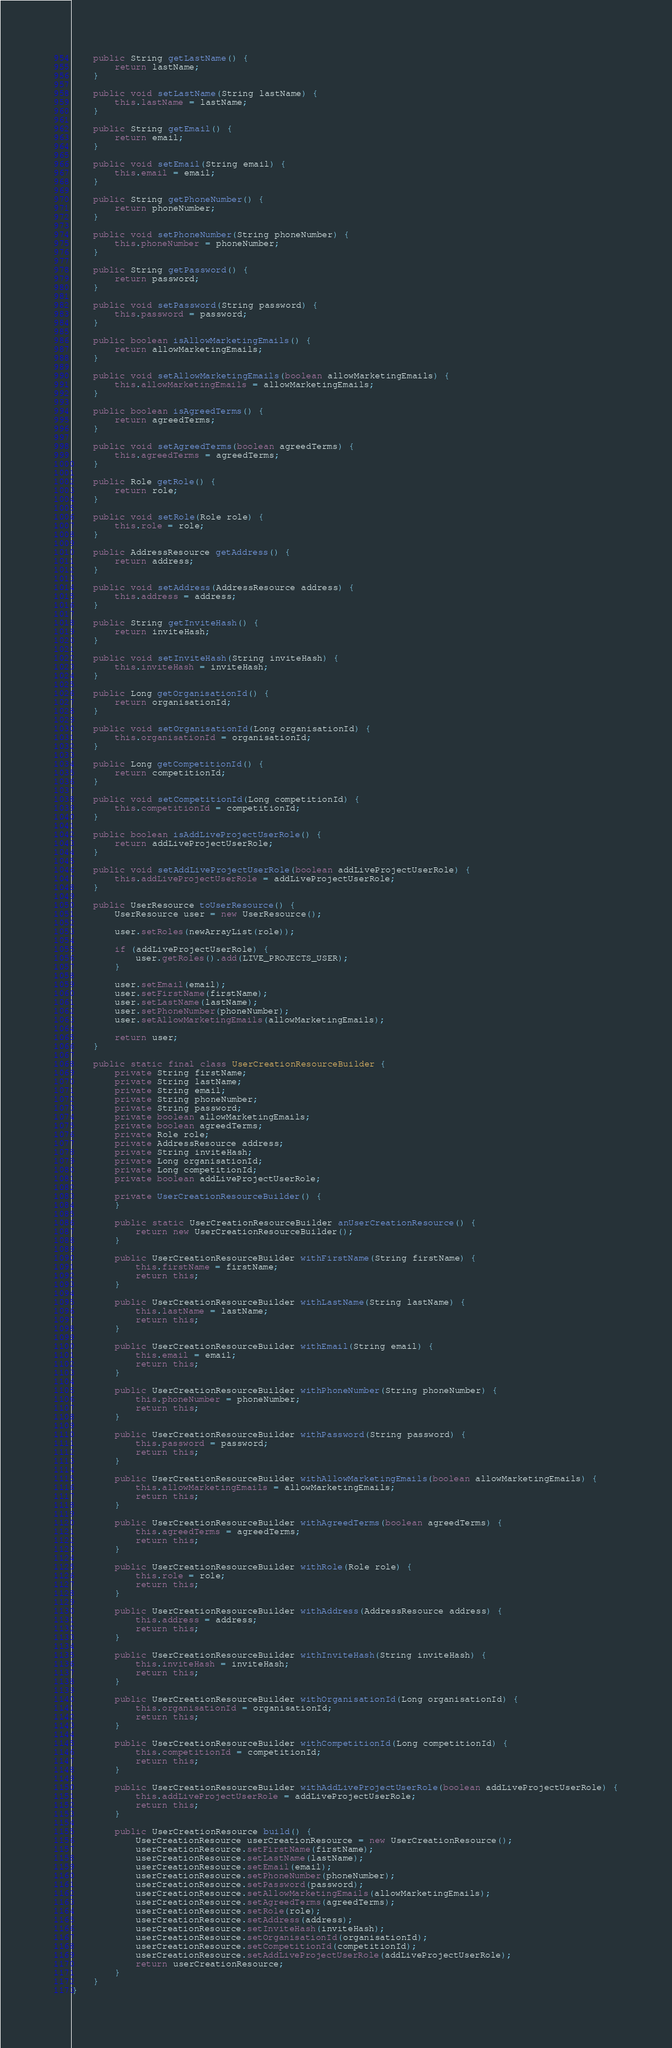Convert code to text. <code><loc_0><loc_0><loc_500><loc_500><_Java_>    public String getLastName() {
        return lastName;
    }

    public void setLastName(String lastName) {
        this.lastName = lastName;
    }

    public String getEmail() {
        return email;
    }

    public void setEmail(String email) {
        this.email = email;
    }

    public String getPhoneNumber() {
        return phoneNumber;
    }

    public void setPhoneNumber(String phoneNumber) {
        this.phoneNumber = phoneNumber;
    }

    public String getPassword() {
        return password;
    }

    public void setPassword(String password) {
        this.password = password;
    }

    public boolean isAllowMarketingEmails() {
        return allowMarketingEmails;
    }

    public void setAllowMarketingEmails(boolean allowMarketingEmails) {
        this.allowMarketingEmails = allowMarketingEmails;
    }

    public boolean isAgreedTerms() {
        return agreedTerms;
    }

    public void setAgreedTerms(boolean agreedTerms) {
        this.agreedTerms = agreedTerms;
    }

    public Role getRole() {
        return role;
    }

    public void setRole(Role role) {
        this.role = role;
    }

    public AddressResource getAddress() {
        return address;
    }

    public void setAddress(AddressResource address) {
        this.address = address;
    }

    public String getInviteHash() {
        return inviteHash;
    }

    public void setInviteHash(String inviteHash) {
        this.inviteHash = inviteHash;
    }

    public Long getOrganisationId() {
        return organisationId;
    }

    public void setOrganisationId(Long organisationId) {
        this.organisationId = organisationId;
    }

    public Long getCompetitionId() {
        return competitionId;
    }

    public void setCompetitionId(Long competitionId) {
        this.competitionId = competitionId;
    }

    public boolean isAddLiveProjectUserRole() {
        return addLiveProjectUserRole;
    }

    public void setAddLiveProjectUserRole(boolean addLiveProjectUserRole) {
        this.addLiveProjectUserRole = addLiveProjectUserRole;
    }

    public UserResource toUserResource() {
        UserResource user = new UserResource();

        user.setRoles(newArrayList(role));

        if (addLiveProjectUserRole) {
            user.getRoles().add(LIVE_PROJECTS_USER);
        }

        user.setEmail(email);
        user.setFirstName(firstName);
        user.setLastName(lastName);
        user.setPhoneNumber(phoneNumber);
        user.setAllowMarketingEmails(allowMarketingEmails);

        return user;
    }

    public static final class UserCreationResourceBuilder {
        private String firstName;
        private String lastName;
        private String email;
        private String phoneNumber;
        private String password;
        private boolean allowMarketingEmails;
        private boolean agreedTerms;
        private Role role;
        private AddressResource address;
        private String inviteHash;
        private Long organisationId;
        private Long competitionId;
        private boolean addLiveProjectUserRole;

        private UserCreationResourceBuilder() {
        }

        public static UserCreationResourceBuilder anUserCreationResource() {
            return new UserCreationResourceBuilder();
        }

        public UserCreationResourceBuilder withFirstName(String firstName) {
            this.firstName = firstName;
            return this;
        }

        public UserCreationResourceBuilder withLastName(String lastName) {
            this.lastName = lastName;
            return this;
        }

        public UserCreationResourceBuilder withEmail(String email) {
            this.email = email;
            return this;
        }

        public UserCreationResourceBuilder withPhoneNumber(String phoneNumber) {
            this.phoneNumber = phoneNumber;
            return this;
        }

        public UserCreationResourceBuilder withPassword(String password) {
            this.password = password;
            return this;
        }

        public UserCreationResourceBuilder withAllowMarketingEmails(boolean allowMarketingEmails) {
            this.allowMarketingEmails = allowMarketingEmails;
            return this;
        }

        public UserCreationResourceBuilder withAgreedTerms(boolean agreedTerms) {
            this.agreedTerms = agreedTerms;
            return this;
        }

        public UserCreationResourceBuilder withRole(Role role) {
            this.role = role;
            return this;
        }

        public UserCreationResourceBuilder withAddress(AddressResource address) {
            this.address = address;
            return this;
        }

        public UserCreationResourceBuilder withInviteHash(String inviteHash) {
            this.inviteHash = inviteHash;
            return this;
        }

        public UserCreationResourceBuilder withOrganisationId(Long organisationId) {
            this.organisationId = organisationId;
            return this;
        }

        public UserCreationResourceBuilder withCompetitionId(Long competitionId) {
            this.competitionId = competitionId;
            return this;
        }

        public UserCreationResourceBuilder withAddLiveProjectUserRole(boolean addLiveProjectUserRole) {
            this.addLiveProjectUserRole = addLiveProjectUserRole;
            return this;
        }

        public UserCreationResource build() {
            UserCreationResource userCreationResource = new UserCreationResource();
            userCreationResource.setFirstName(firstName);
            userCreationResource.setLastName(lastName);
            userCreationResource.setEmail(email);
            userCreationResource.setPhoneNumber(phoneNumber);
            userCreationResource.setPassword(password);
            userCreationResource.setAllowMarketingEmails(allowMarketingEmails);
            userCreationResource.setAgreedTerms(agreedTerms);
            userCreationResource.setRole(role);
            userCreationResource.setAddress(address);
            userCreationResource.setInviteHash(inviteHash);
            userCreationResource.setOrganisationId(organisationId);
            userCreationResource.setCompetitionId(competitionId);
            userCreationResource.setAddLiveProjectUserRole(addLiveProjectUserRole);
            return userCreationResource;
        }
    }
}</code> 